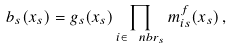Convert formula to latex. <formula><loc_0><loc_0><loc_500><loc_500>b _ { s } ( x _ { s } ) = g _ { s } ( x _ { s } ) \prod _ { i \in \ n b r _ { s } } m ^ { f } _ { i s } ( x _ { s } ) \, ,</formula> 